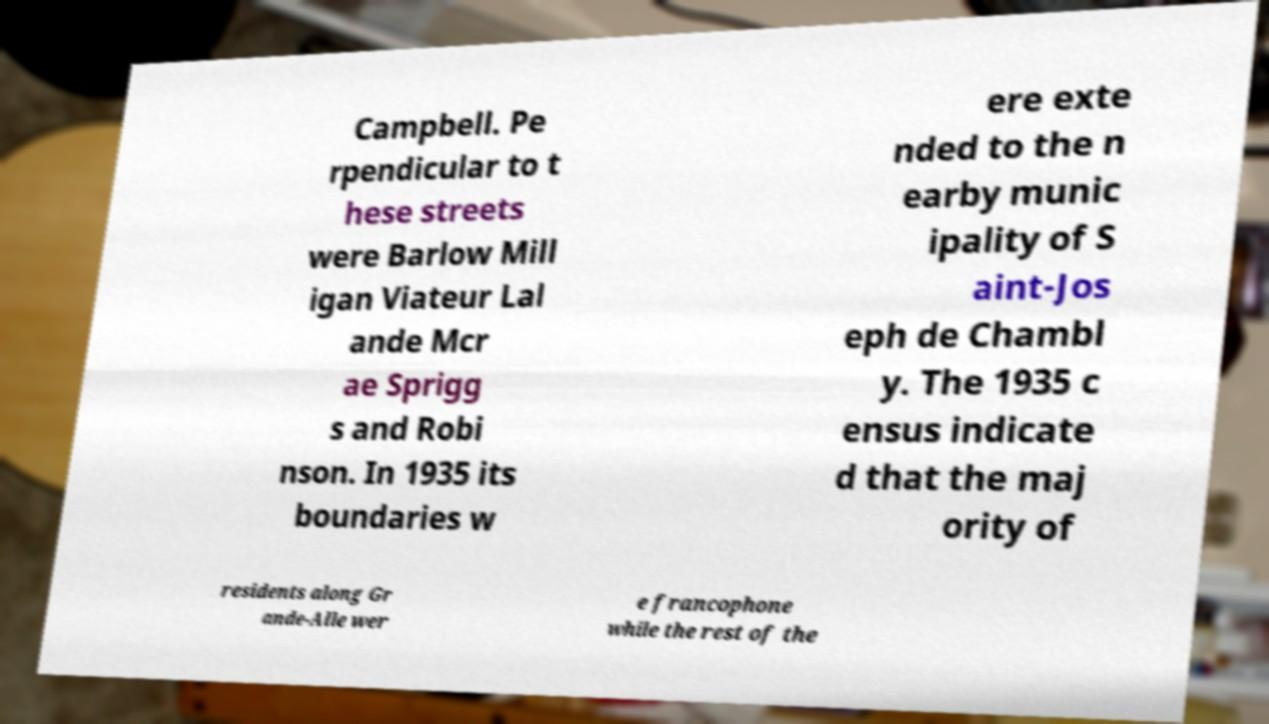Can you accurately transcribe the text from the provided image for me? Campbell. Pe rpendicular to t hese streets were Barlow Mill igan Viateur Lal ande Mcr ae Sprigg s and Robi nson. In 1935 its boundaries w ere exte nded to the n earby munic ipality of S aint-Jos eph de Chambl y. The 1935 c ensus indicate d that the maj ority of residents along Gr ande-Alle wer e francophone while the rest of the 